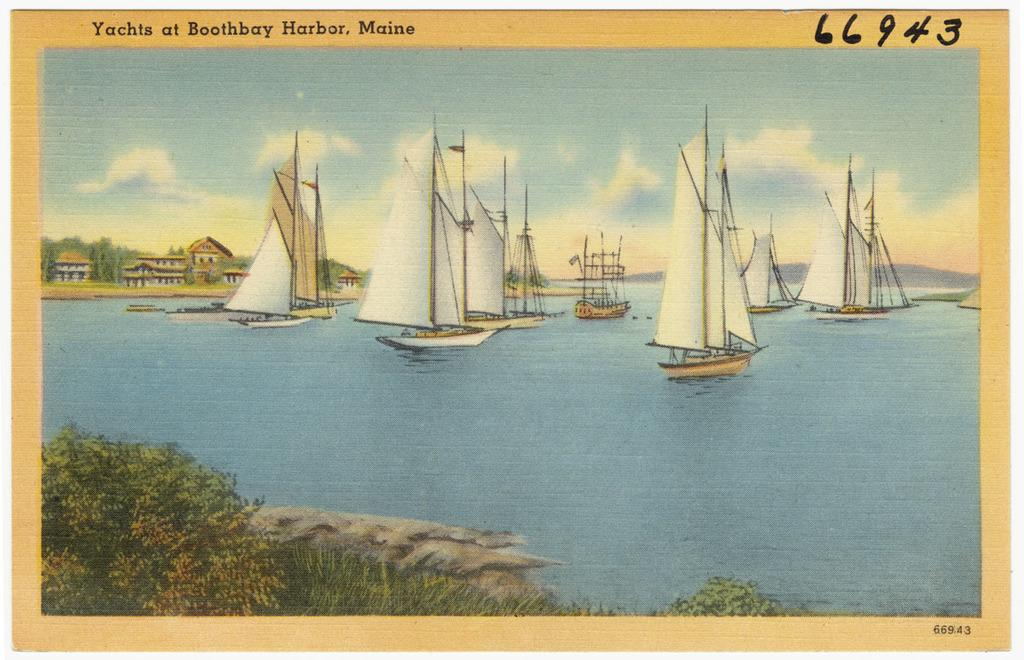Provide a one-sentence caption for the provided image. Several sailboats can be seen in the painting at Boothbay Harbor, Maine. 